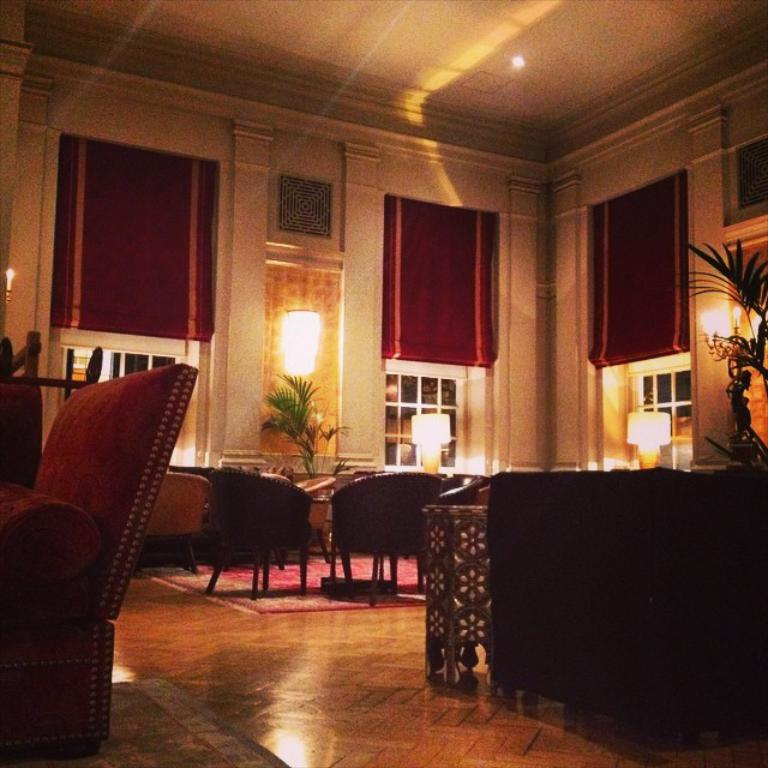What type of furniture is present in the image? There is a couch, chairs, and a table in the image. What decorative items can be seen in the image? There are flower pots and lamps in the image. What architectural features are visible in the image? There are windows in the image. What type of window treatment is present in the image? There are red curtains in the image. What year is depicted in the image? The image does not depict a specific year; it is a still image of a room with furniture and decorative items. Can you tell me how many wrenches are visible in the image? There are no wrenches present in the image. 